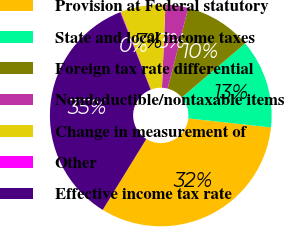<chart> <loc_0><loc_0><loc_500><loc_500><pie_chart><fcel>Provision at Federal statutory<fcel>State and local income taxes<fcel>Foreign tax rate differential<fcel>Nondeductible/nontaxable items<fcel>Change in measurement of<fcel>Other<fcel>Effective income tax rate<nl><fcel>32.05%<fcel>12.98%<fcel>9.76%<fcel>3.31%<fcel>6.54%<fcel>0.09%<fcel>35.27%<nl></chart> 